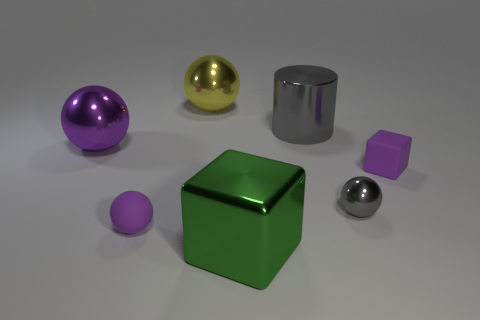Are there any other things of the same color as the metallic block?
Make the answer very short. No. There is a small purple object that is the same material as the purple block; what shape is it?
Give a very brief answer. Sphere. What material is the object that is in front of the tiny purple rubber thing on the left side of the purple block made of?
Provide a short and direct response. Metal. Does the small purple rubber object that is on the right side of the large yellow ball have the same shape as the green metal object?
Offer a very short reply. Yes. Are there more small gray metallic objects that are in front of the tiny shiny thing than yellow metal cylinders?
Offer a very short reply. No. Is there anything else that has the same material as the large gray cylinder?
Provide a short and direct response. Yes. What is the shape of the metal thing that is the same color as the small matte sphere?
Provide a short and direct response. Sphere. What number of blocks are either large purple shiny things or tiny purple things?
Your answer should be compact. 1. What is the color of the tiny sphere behind the purple sphere in front of the large purple ball?
Give a very brief answer. Gray. Do the tiny rubber cube and the large metallic thing in front of the tiny purple ball have the same color?
Provide a short and direct response. No. 